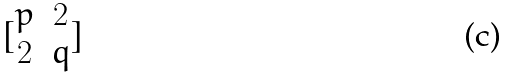<formula> <loc_0><loc_0><loc_500><loc_500>[ \begin{matrix} p & 2 \\ 2 & q \end{matrix} ]</formula> 